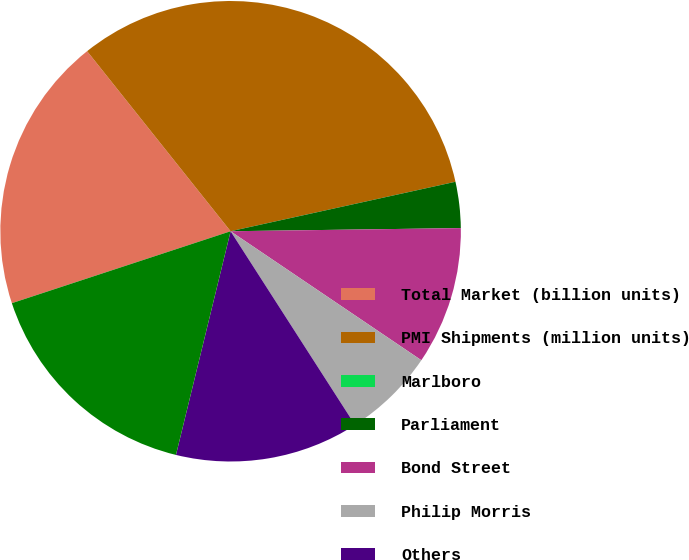Convert chart to OTSL. <chart><loc_0><loc_0><loc_500><loc_500><pie_chart><fcel>Total Market (billion units)<fcel>PMI Shipments (million units)<fcel>Marlboro<fcel>Parliament<fcel>Bond Street<fcel>Philip Morris<fcel>Others<fcel>Total<nl><fcel>19.35%<fcel>32.26%<fcel>0.0%<fcel>3.23%<fcel>9.68%<fcel>6.45%<fcel>12.9%<fcel>16.13%<nl></chart> 